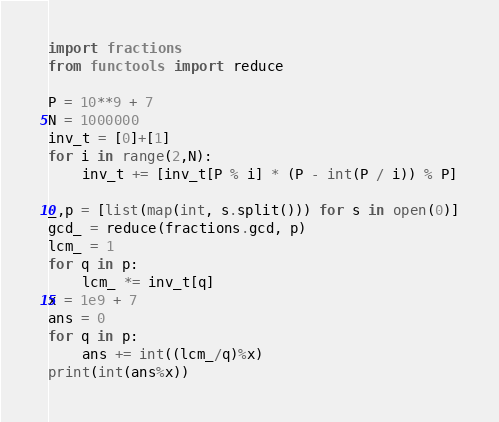<code> <loc_0><loc_0><loc_500><loc_500><_Python_>import fractions
from functools import reduce

P = 10**9 + 7
N = 1000000
inv_t = [0]+[1]
for i in range(2,N):
    inv_t += [inv_t[P % i] * (P - int(P / i)) % P]

_,p = [list(map(int, s.split())) for s in open(0)]
gcd_ = reduce(fractions.gcd, p)
lcm_ = 1
for q in p:
    lcm_ *= inv_t[q]
x = 1e9 + 7
ans = 0
for q in p:
    ans += int((lcm_/q)%x)
print(int(ans%x))</code> 